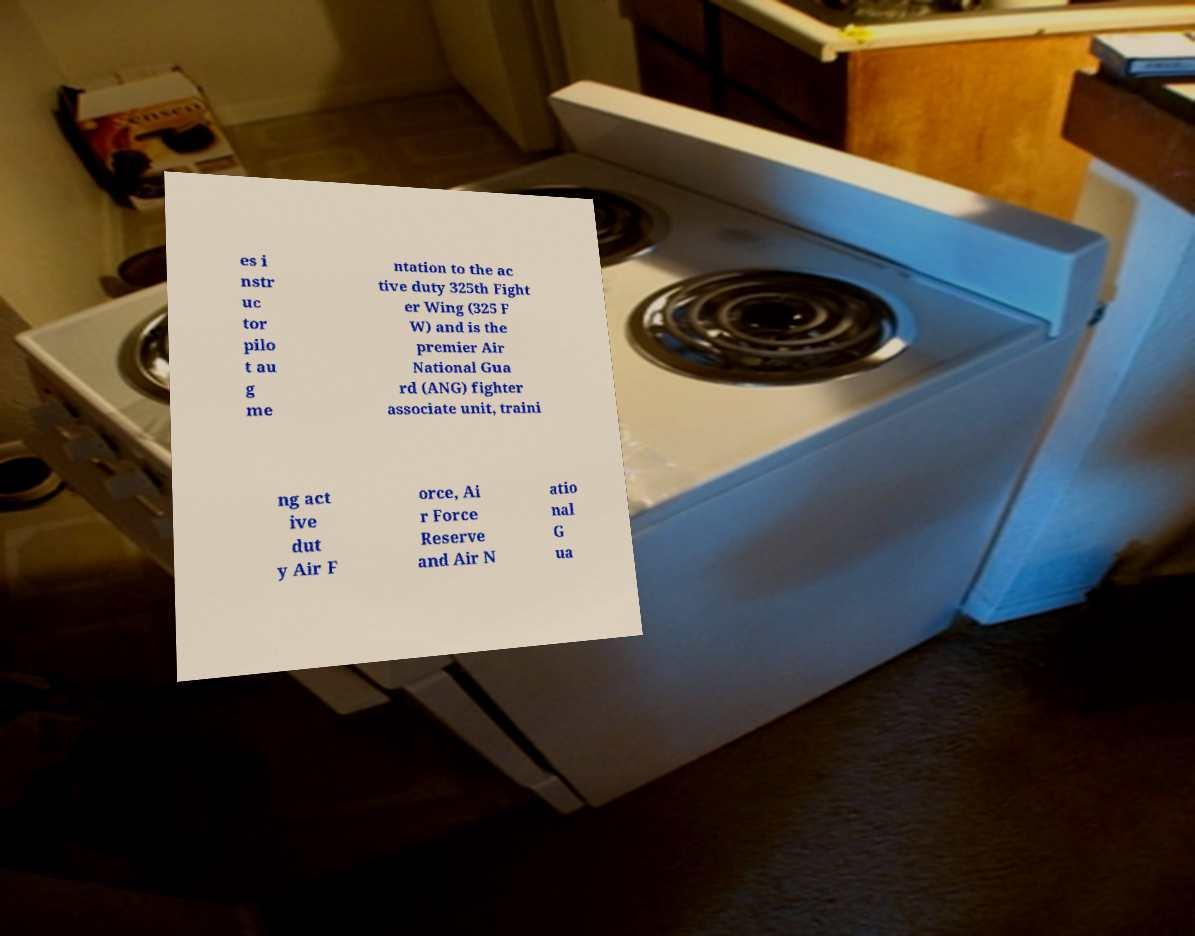Can you accurately transcribe the text from the provided image for me? es i nstr uc tor pilo t au g me ntation to the ac tive duty 325th Fight er Wing (325 F W) and is the premier Air National Gua rd (ANG) fighter associate unit, traini ng act ive dut y Air F orce, Ai r Force Reserve and Air N atio nal G ua 